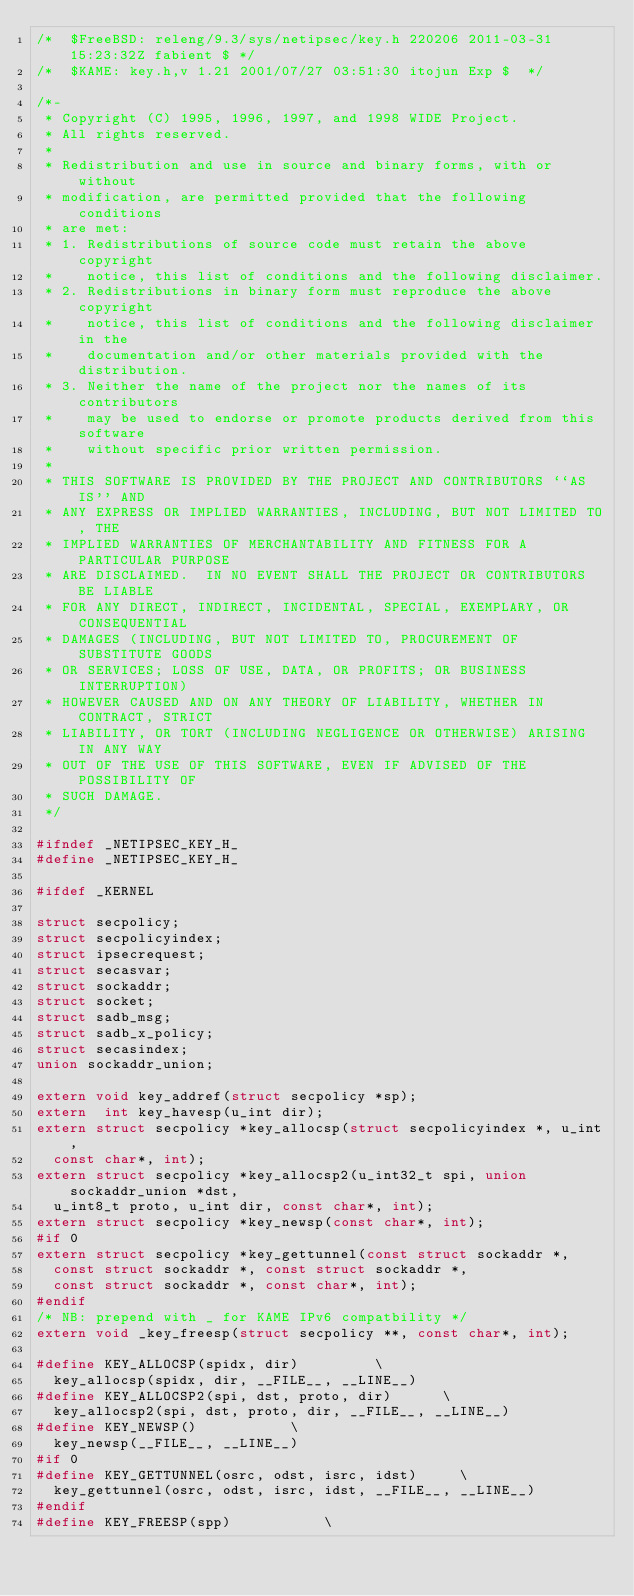Convert code to text. <code><loc_0><loc_0><loc_500><loc_500><_C_>/*	$FreeBSD: releng/9.3/sys/netipsec/key.h 220206 2011-03-31 15:23:32Z fabient $	*/
/*	$KAME: key.h,v 1.21 2001/07/27 03:51:30 itojun Exp $	*/

/*-
 * Copyright (C) 1995, 1996, 1997, and 1998 WIDE Project.
 * All rights reserved.
 *
 * Redistribution and use in source and binary forms, with or without
 * modification, are permitted provided that the following conditions
 * are met:
 * 1. Redistributions of source code must retain the above copyright
 *    notice, this list of conditions and the following disclaimer.
 * 2. Redistributions in binary form must reproduce the above copyright
 *    notice, this list of conditions and the following disclaimer in the
 *    documentation and/or other materials provided with the distribution.
 * 3. Neither the name of the project nor the names of its contributors
 *    may be used to endorse or promote products derived from this software
 *    without specific prior written permission.
 *
 * THIS SOFTWARE IS PROVIDED BY THE PROJECT AND CONTRIBUTORS ``AS IS'' AND
 * ANY EXPRESS OR IMPLIED WARRANTIES, INCLUDING, BUT NOT LIMITED TO, THE
 * IMPLIED WARRANTIES OF MERCHANTABILITY AND FITNESS FOR A PARTICULAR PURPOSE
 * ARE DISCLAIMED.  IN NO EVENT SHALL THE PROJECT OR CONTRIBUTORS BE LIABLE
 * FOR ANY DIRECT, INDIRECT, INCIDENTAL, SPECIAL, EXEMPLARY, OR CONSEQUENTIAL
 * DAMAGES (INCLUDING, BUT NOT LIMITED TO, PROCUREMENT OF SUBSTITUTE GOODS
 * OR SERVICES; LOSS OF USE, DATA, OR PROFITS; OR BUSINESS INTERRUPTION)
 * HOWEVER CAUSED AND ON ANY THEORY OF LIABILITY, WHETHER IN CONTRACT, STRICT
 * LIABILITY, OR TORT (INCLUDING NEGLIGENCE OR OTHERWISE) ARISING IN ANY WAY
 * OUT OF THE USE OF THIS SOFTWARE, EVEN IF ADVISED OF THE POSSIBILITY OF
 * SUCH DAMAGE.
 */

#ifndef _NETIPSEC_KEY_H_
#define _NETIPSEC_KEY_H_

#ifdef _KERNEL

struct secpolicy;
struct secpolicyindex;
struct ipsecrequest;
struct secasvar;
struct sockaddr;
struct socket;
struct sadb_msg;
struct sadb_x_policy;
struct secasindex;
union sockaddr_union;

extern void key_addref(struct secpolicy *sp);
extern	int key_havesp(u_int dir);
extern struct secpolicy *key_allocsp(struct secpolicyindex *, u_int,
	const char*, int);
extern struct secpolicy *key_allocsp2(u_int32_t spi, union sockaddr_union *dst,
	u_int8_t proto, u_int dir, const char*, int);
extern struct secpolicy *key_newsp(const char*, int);
#if 0
extern struct secpolicy *key_gettunnel(const struct sockaddr *,
	const struct sockaddr *, const struct sockaddr *,
	const struct sockaddr *, const char*, int);
#endif
/* NB: prepend with _ for KAME IPv6 compatbility */
extern void _key_freesp(struct secpolicy **, const char*, int);

#define	KEY_ALLOCSP(spidx, dir)					\
	key_allocsp(spidx, dir, __FILE__, __LINE__)
#define	KEY_ALLOCSP2(spi, dst, proto, dir)			\
	key_allocsp2(spi, dst, proto, dir, __FILE__, __LINE__)
#define	KEY_NEWSP()						\
	key_newsp(__FILE__, __LINE__)
#if 0
#define	KEY_GETTUNNEL(osrc, odst, isrc, idst)			\
	key_gettunnel(osrc, odst, isrc, idst, __FILE__, __LINE__)
#endif
#define	KEY_FREESP(spp)						\</code> 